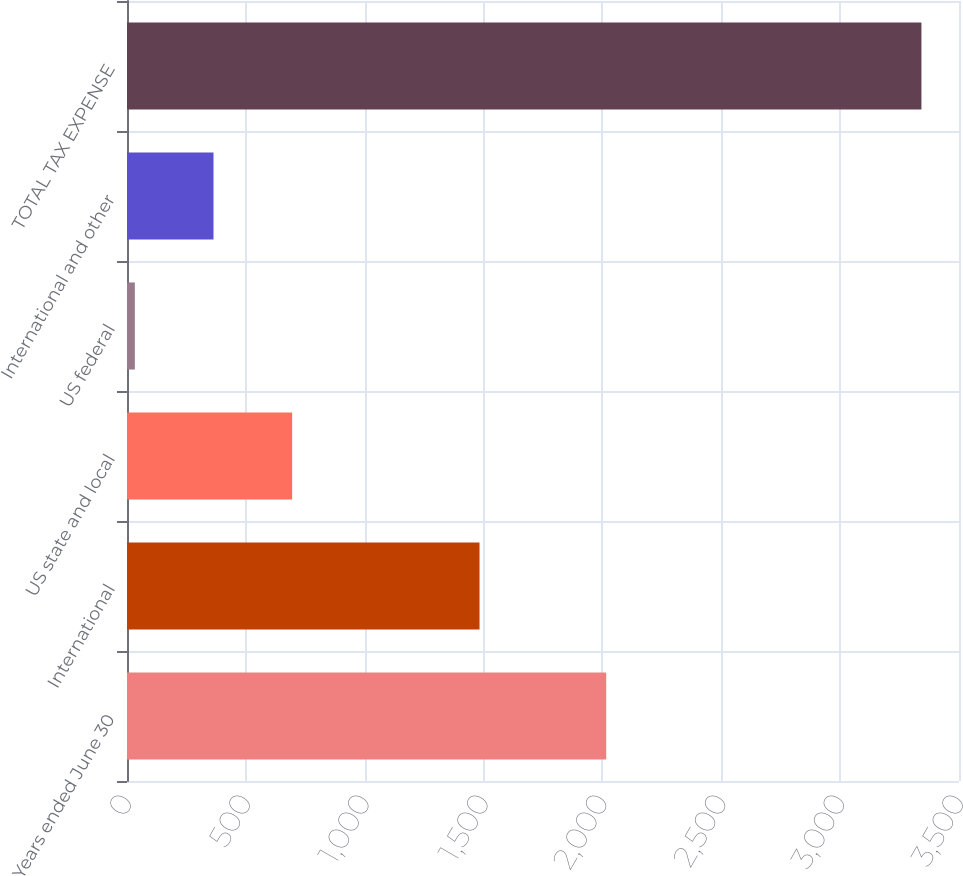<chart> <loc_0><loc_0><loc_500><loc_500><bar_chart><fcel>Years ended June 30<fcel>International<fcel>US state and local<fcel>US federal<fcel>International and other<fcel>TOTAL TAX EXPENSE<nl><fcel>2016<fcel>1483<fcel>694.8<fcel>33<fcel>363.9<fcel>3342<nl></chart> 